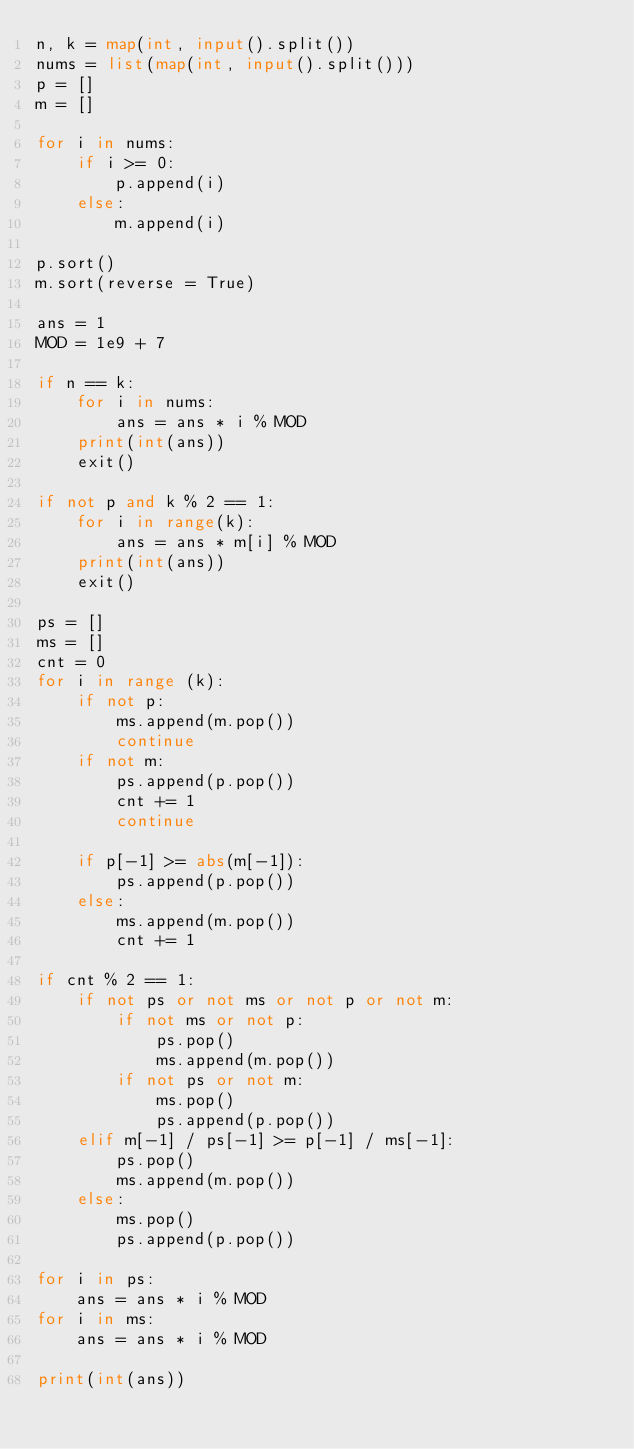<code> <loc_0><loc_0><loc_500><loc_500><_Python_>n, k = map(int, input().split())
nums = list(map(int, input().split()))
p = []
m = []

for i in nums:
    if i >= 0:
        p.append(i)
    else:
        m.append(i)

p.sort()
m.sort(reverse = True)

ans = 1
MOD = 1e9 + 7

if n == k:
    for i in nums:
        ans = ans * i % MOD
    print(int(ans))
    exit()

if not p and k % 2 == 1:
    for i in range(k):
        ans = ans * m[i] % MOD
    print(int(ans))
    exit()

ps = []
ms = []
cnt = 0
for i in range (k):
    if not p:
        ms.append(m.pop())
        continue
    if not m:
        ps.append(p.pop())
        cnt += 1
        continue
    
    if p[-1] >= abs(m[-1]):
        ps.append(p.pop())
    else:
        ms.append(m.pop())
        cnt += 1

if cnt % 2 == 1:
    if not ps or not ms or not p or not m:  
        if not ms or not p:
            ps.pop()
            ms.append(m.pop())
        if not ps or not m:
            ms.pop()
            ps.append(p.pop())
    elif m[-1] / ps[-1] >= p[-1] / ms[-1]:
        ps.pop()
        ms.append(m.pop())
    else:
        ms.pop()
        ps.append(p.pop())

for i in ps:
    ans = ans * i % MOD
for i in ms:
    ans = ans * i % MOD

print(int(ans))</code> 